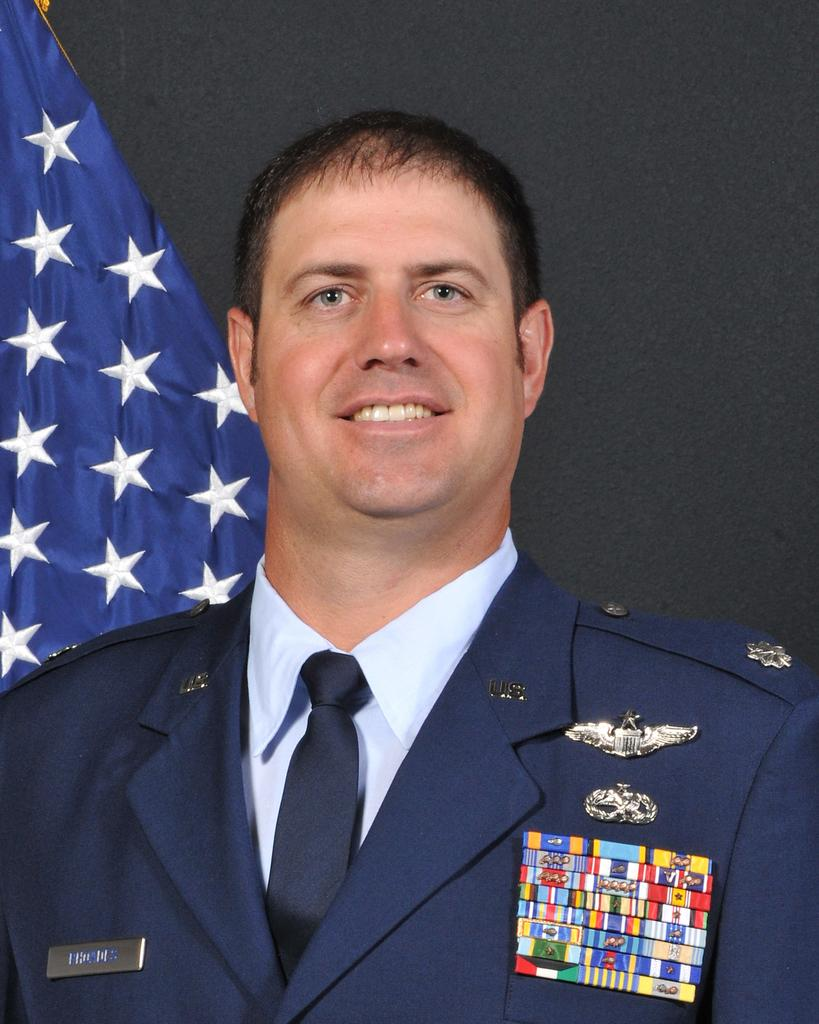Who is present in the image? There is a man in the image. What is the man doing in the image? The man is smiling in the image. What is the man wearing in the image? The man is wearing a blazer in the image. Are there any additional details on the man's blazer? Yes, there are badges on the man's blazer. What can be seen to the left of the man in the image? There is a flag to the left of the man in the image. What is behind the man in the image? There is a wall behind the man in the image. Can you touch the man's wing in the image? There is no wing present in the image, so it cannot be touched. 